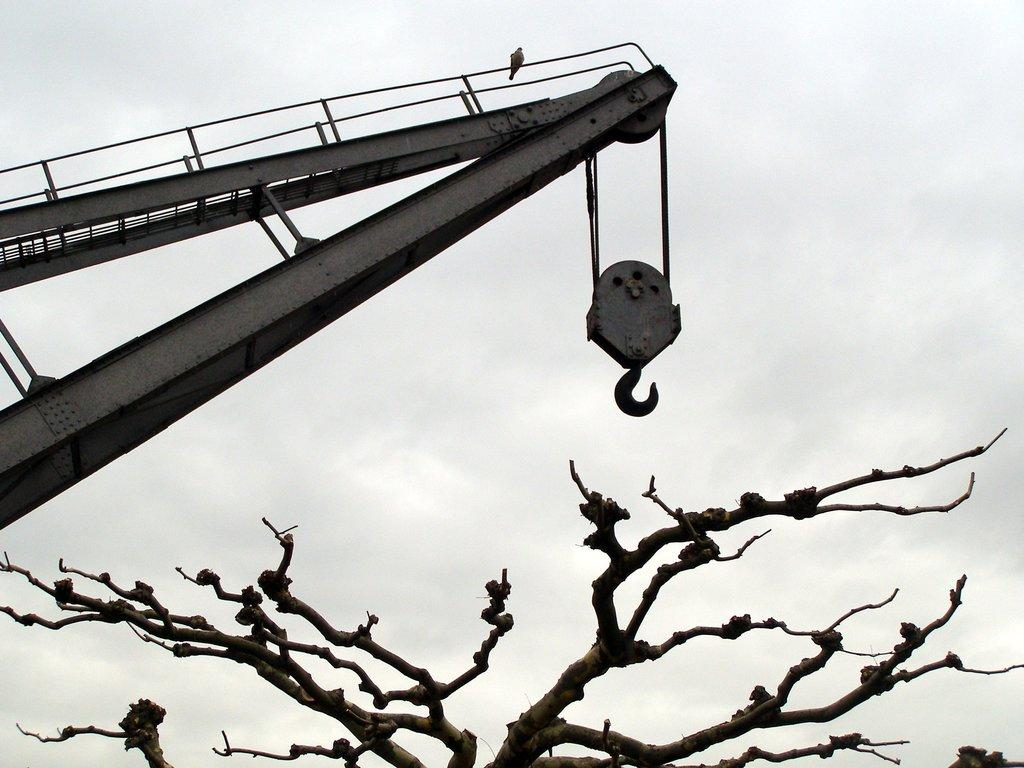What is the main object in the image? There is a crane with a hook in the image. What is located above the crane? There is a bird above the crane in the image. What is located below the hook of the crane? There is a dry tree below the hook in the image. What can be seen in the background of the image? The sky is visible in the background of the image. What type of butter is being used by the band in the image? There is no band or butter present in the image. 